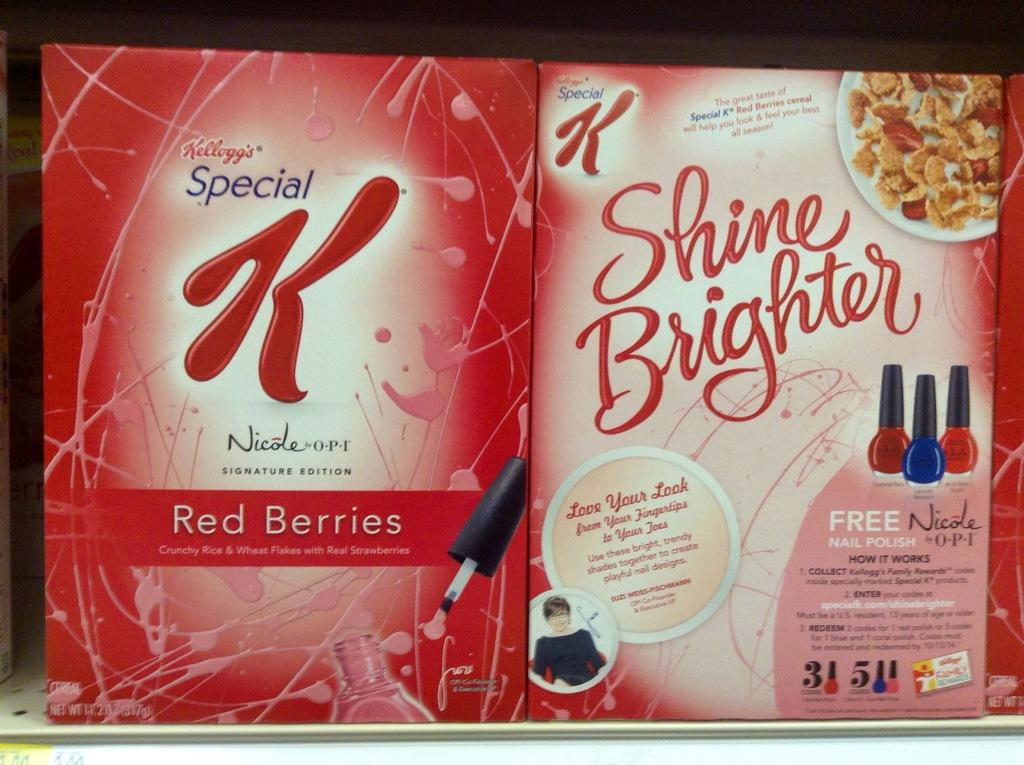How many posters are visible in the image? There are two posters in the image. What can be found on the posters? The posters contain text, depict a person, show food items, and display nail polishes. What is the primary subject of the posters? The posters depict a person and show food items and nail polishes. How many frogs are sitting on the nail polish bottles in the image? There are no frogs present in the image, and therefore no frogs are sitting on the nail polish bottles. 